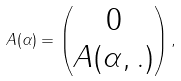Convert formula to latex. <formula><loc_0><loc_0><loc_500><loc_500>\ A ( \alpha ) = \begin{pmatrix} 0 \\ A ( \alpha , . ) \\ \end{pmatrix} ,</formula> 